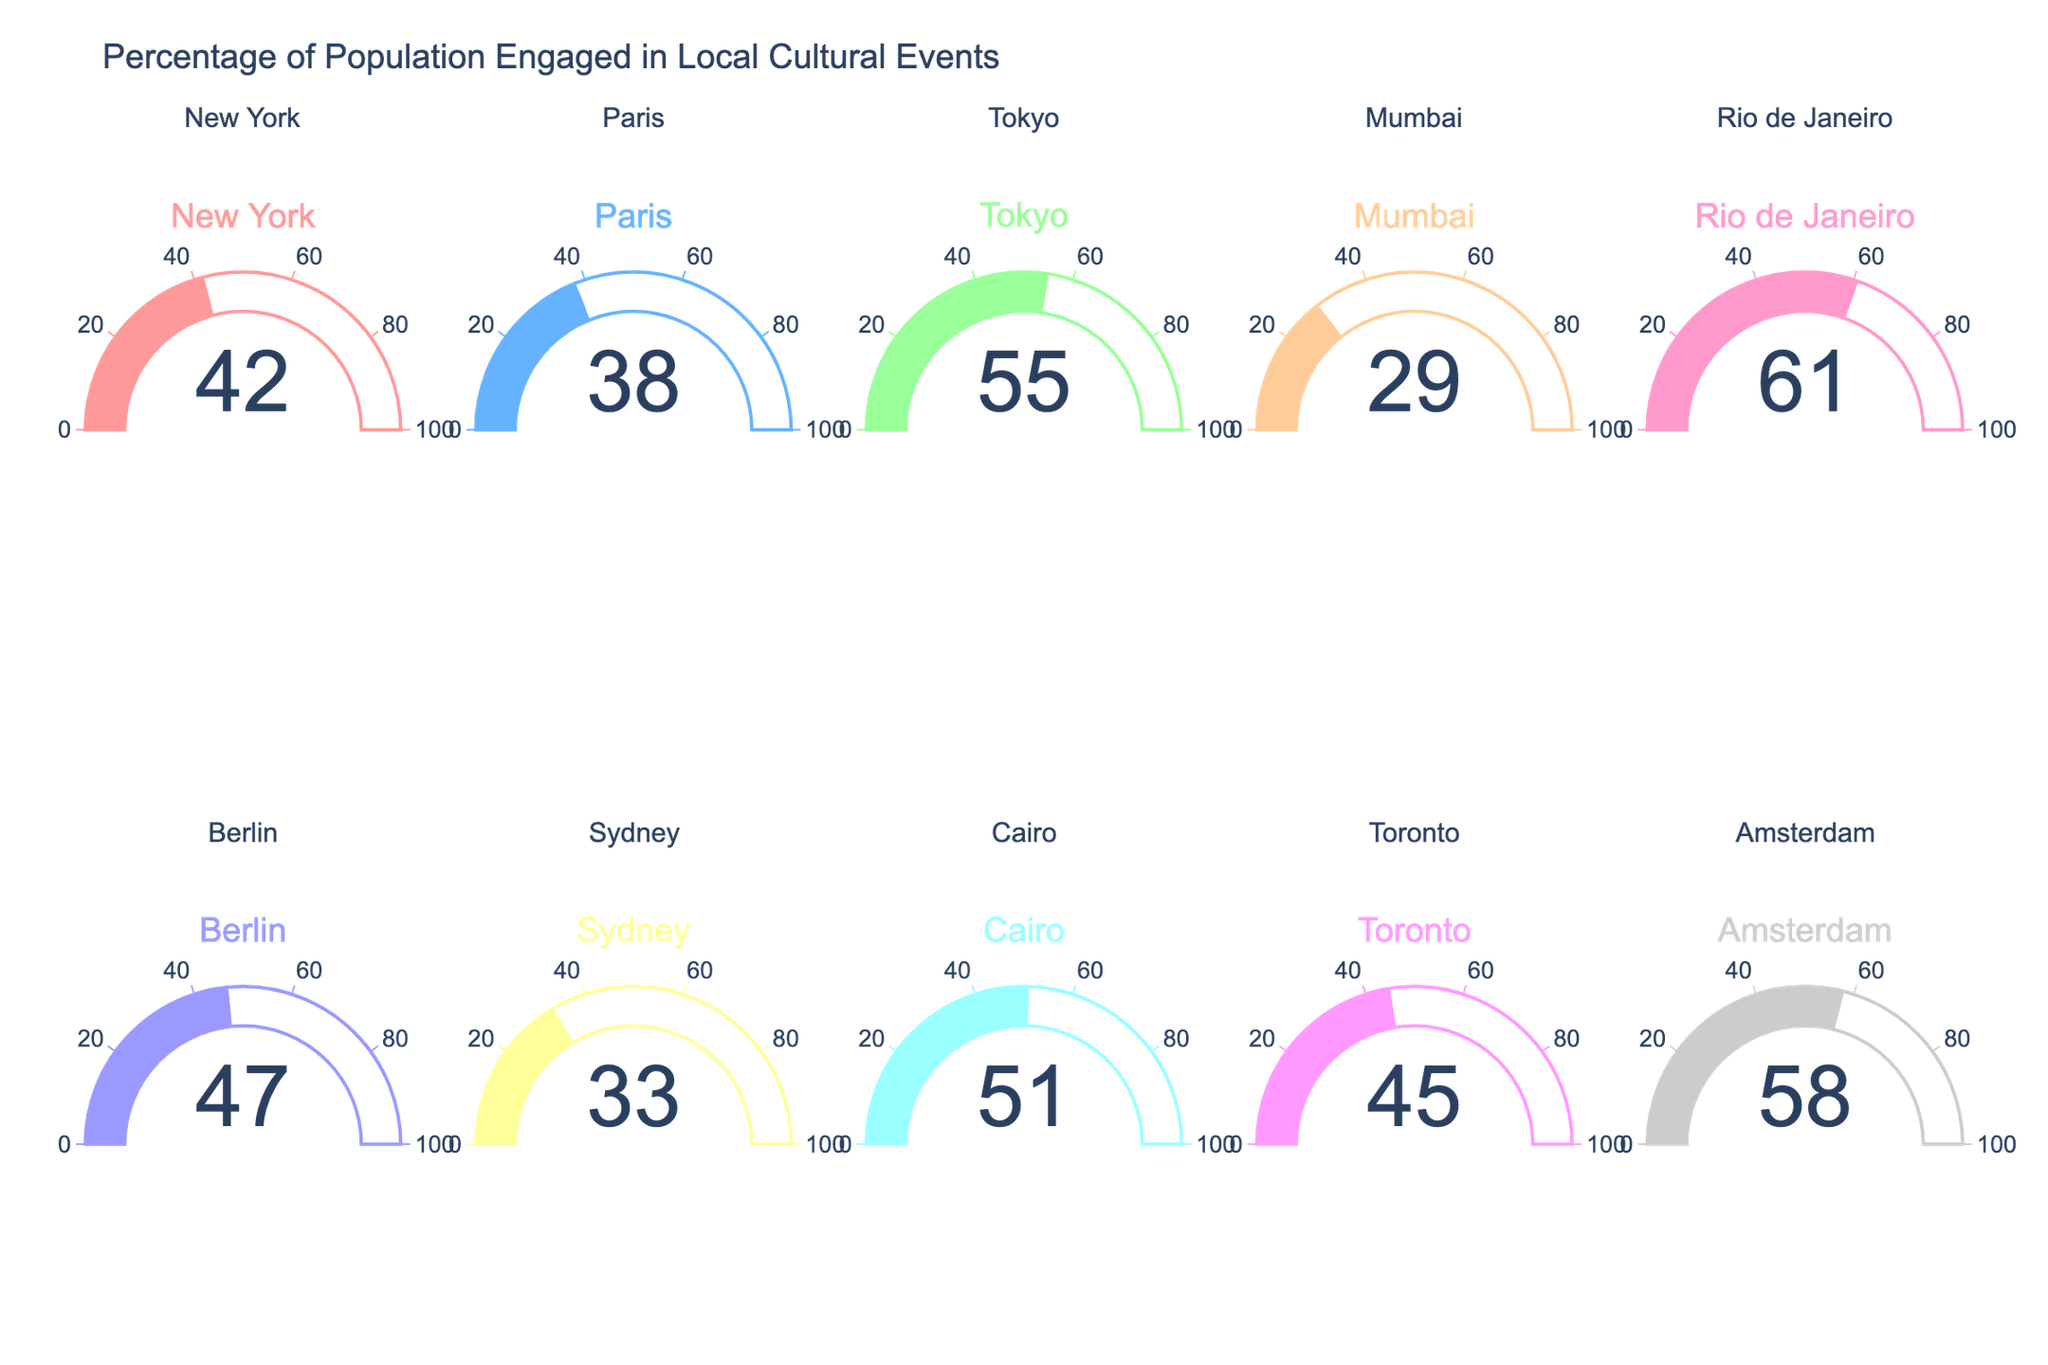What is the percentage of the population engaged in local cultural events in Tokyo? The gauge for Tokyo shows a value of 55%.
Answer: 55% Which city has the highest percentage of engagement in local cultural events? The gauge for Rio de Janeiro shows the highest value at 61%.
Answer: Rio de Janeiro How many cities have a population engagement percentage higher than 50%? The gauges for Tokyo, Rio de Janeiro, and Cairo show engagement values higher than 50%.
Answer: 3 What is the range of the engagement percentages across all cities? The lowest value is 29% (Mumbai) and the highest is 61% (Rio de Janeiro), hence the range is 61% - 29% = 32%.
Answer: 32% Which city has the lowest percentage of population engaged in local cultural events? The gauge for Mumbai shows the lowest value at 29%.
Answer: Mumbai What is the average percentage of population engagement across all cities? Sum all the percentages: 42 + 38 + 55 + 29 + 61 + 47 + 33 + 51 + 45 + 58 = 459. The average is 459 / 10 = 45.9%.
Answer: 45.9% Are there more cities with an engagement percentage above or below 40%? There are 7 cities above 40% (New York, Tokyo, Rio de Janeiro, Berlin, Cairo, Toronto, Amsterdam) and 3 below 40% (Paris, Mumbai, Sydney).
Answer: More above 40% What is the median engagement percentage among these cities? Arranging the percentages in ascending order: 29, 33, 38, 42, 45, 47, 51, 55, 58, 61. The median is the average of the 5th and 6th values: (45 + 47) / 2 = 46%.
Answer: 46% Which cities have engagement percentages within 10 percentage points of the average? The average is 45.9%. Cities within 10% of this average are New York (42), Paris (38), Berlin (47), Sydney (33), Cairo (51), and Toronto (45).
Answer: New York, Paris, Berlin, Sydney, Cairo, Toronto How many cities have engagement percentages between 30% and 50%? The gauges for Paris (38), Mumbai (29), Sydney (33), Berlin (47), and Toronto (45) fall within this range.
Answer: 5 